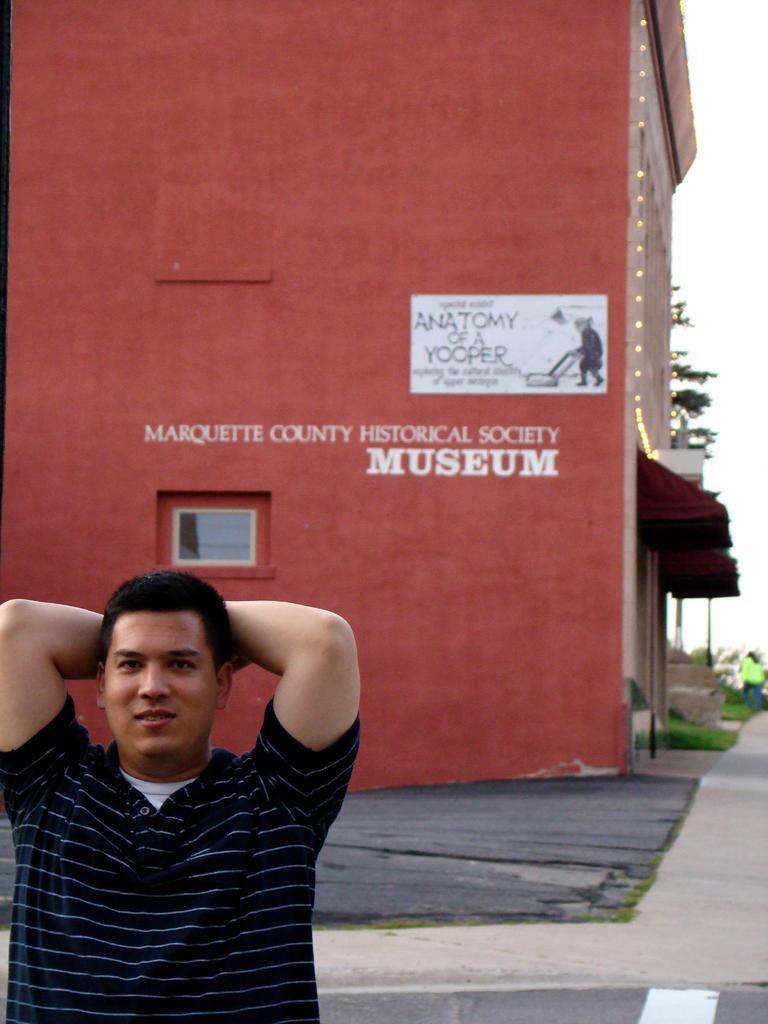Describe this image in one or two sentences. In this image we can see a person. In the background there is a building, trees, road and sky. 